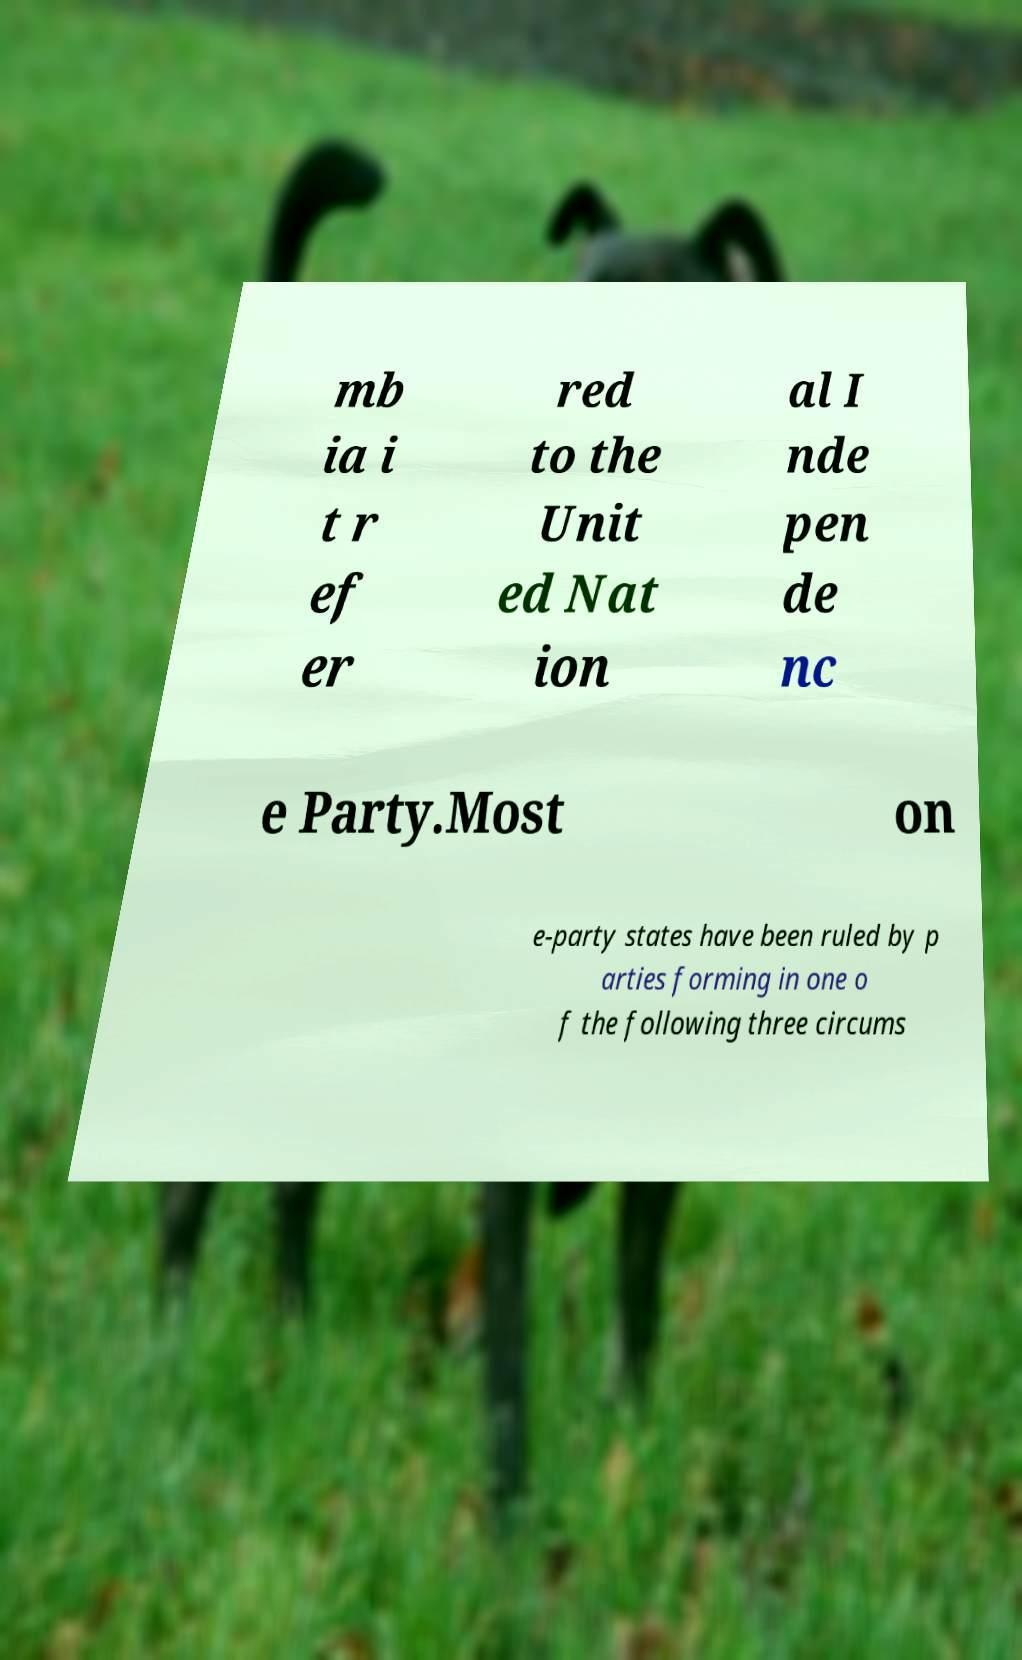Please read and relay the text visible in this image. What does it say? mb ia i t r ef er red to the Unit ed Nat ion al I nde pen de nc e Party.Most on e-party states have been ruled by p arties forming in one o f the following three circums 